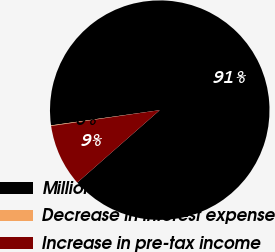Convert chart. <chart><loc_0><loc_0><loc_500><loc_500><pie_chart><fcel>Millions<fcel>Decrease in interest expense<fcel>Increase in pre-tax income<nl><fcel>90.75%<fcel>0.09%<fcel>9.16%<nl></chart> 